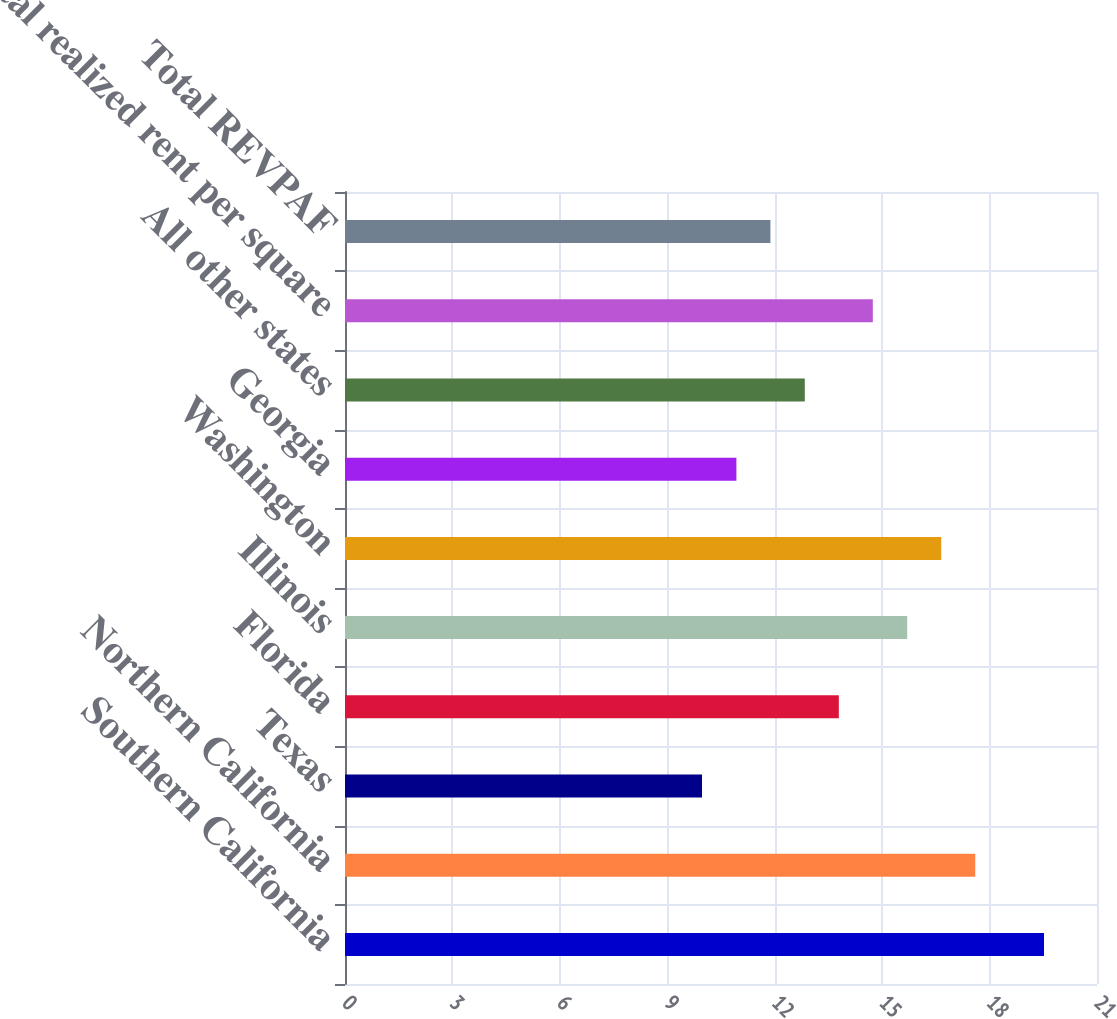Convert chart to OTSL. <chart><loc_0><loc_0><loc_500><loc_500><bar_chart><fcel>Southern California<fcel>Northern California<fcel>Texas<fcel>Florida<fcel>Illinois<fcel>Washington<fcel>Georgia<fcel>All other states<fcel>Total realized rent per square<fcel>Total REVPAF<nl><fcel>19.52<fcel>17.6<fcel>9.97<fcel>13.79<fcel>15.7<fcel>16.65<fcel>10.93<fcel>12.84<fcel>14.74<fcel>11.88<nl></chart> 